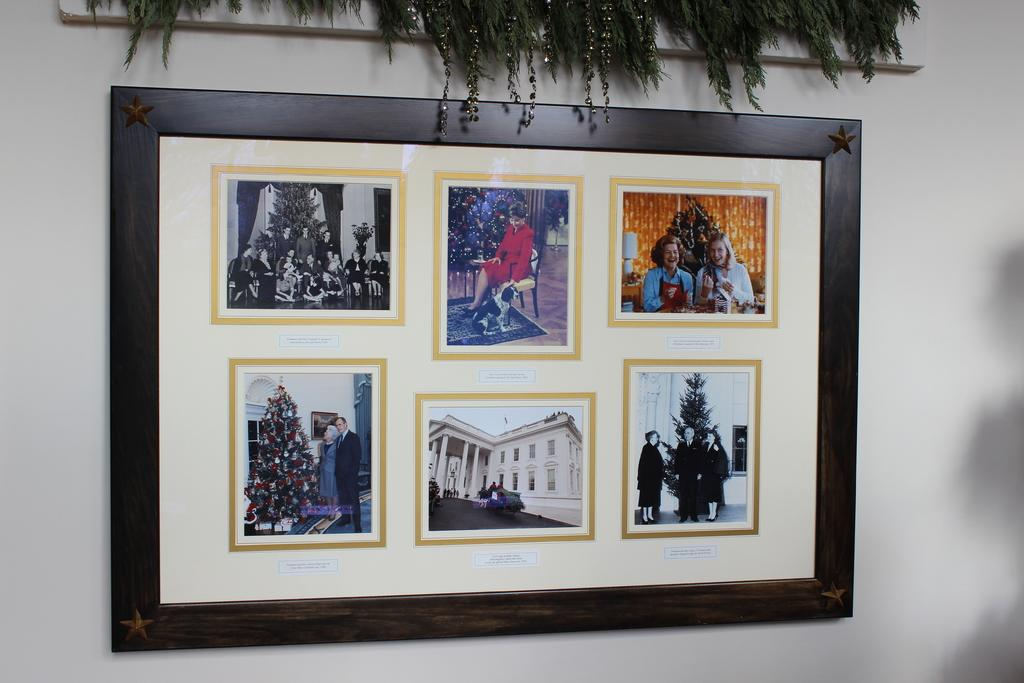What is hanging on the wall in the image? There is a photo frame on the wall. What can be seen inside the photo frame? The photo frame contains images of people. Are there any plants visible in the image? Yes, there are houseplants in the image. How does the regret feel in the image? There is no mention of regret in the image, so it cannot be determined how it might feel. 